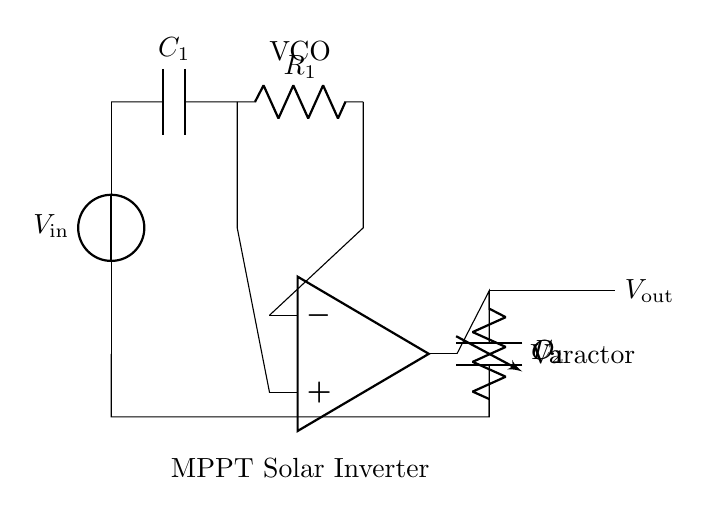What is the function of the operational amplifier in this circuit? The operational amplifier is used to amplify the difference in voltage between its inverting and non-inverting inputs, which helps in generating the desired output frequency for the VCO.
Answer: Amplification Which component is responsible for controlling the output frequency? The varactor diode is the component that adjusts the capacitance based on the applied voltage, effectively controlling the output frequency of the oscillator circuit.
Answer: Varactor diode What is the purpose of the capacitor labeled C2? C2 is used to filter and stabilize the output voltage by smoothing out fluctuations, contributing to a more stable operation of the voltage-controlled oscillator.
Answer: Smoothing How many resistors are present in this circuit? There is one resistor (R1) included in this circuit diagram, which is used in conjunction with the operational amplifier for feedback and stability.
Answer: One What does MPPT stand for in this context? MPPT stands for Maximum Power Point Tracking, which refers to the technique used in solar inverters to optimize the energy harvested from a solar panel by adjusting the operating point.
Answer: Maximum Power Point Tracking What is the input voltage denoted in this circuit? The input voltage, represented by V_in, is typically the voltage supplied to the oscillator circuit, which is a critical parameter for its functioning.
Answer: V_in What type of circuit is illustrated in the provided diagram? The diagram represents a voltage-controlled oscillator circuit specialized for maximum power point tracking in solar inverters, aimed at optimizing solar power output.
Answer: Voltage-controlled oscillator 